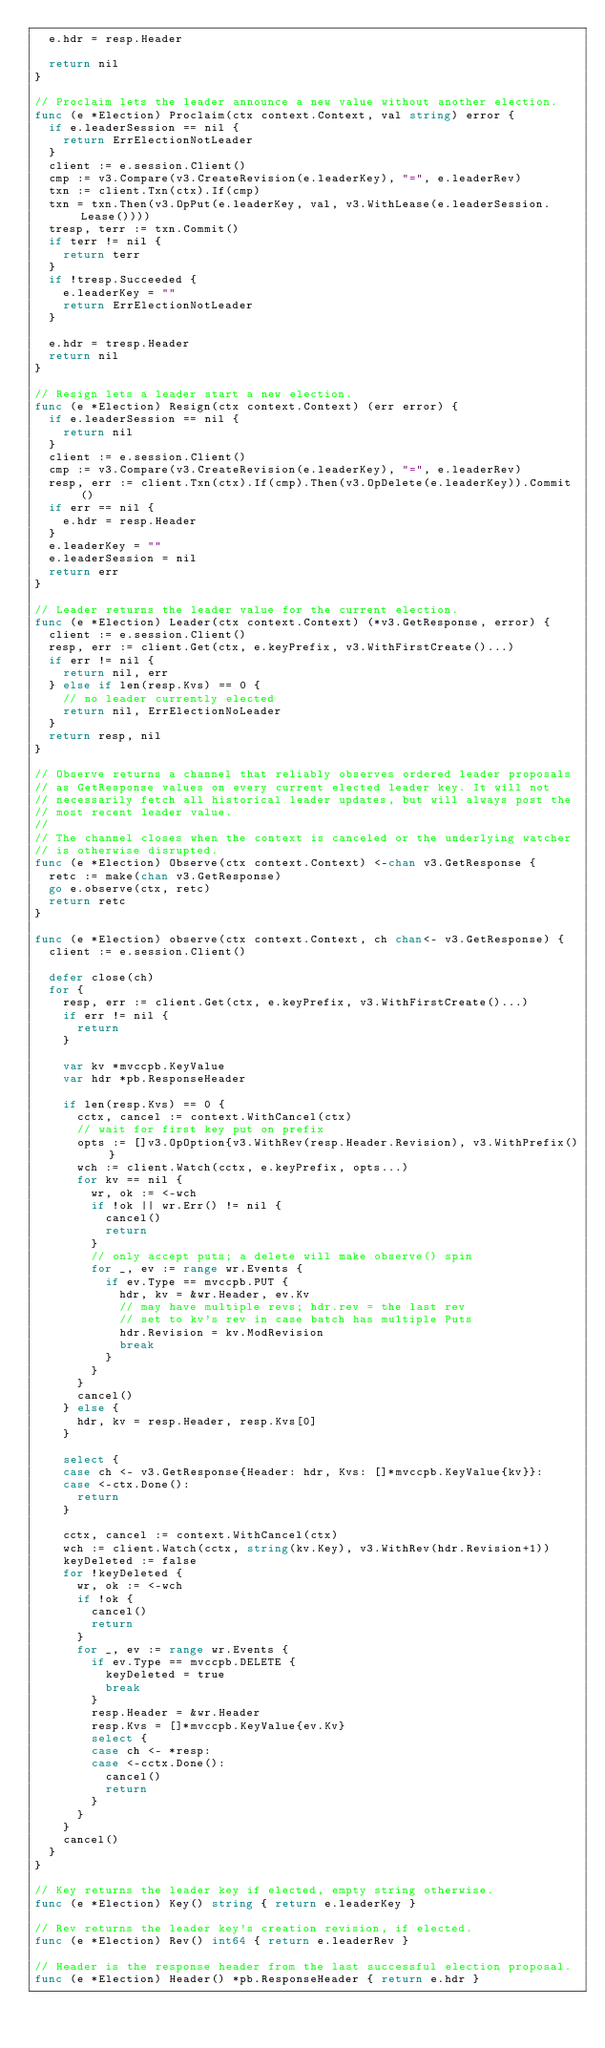<code> <loc_0><loc_0><loc_500><loc_500><_Go_>	e.hdr = resp.Header

	return nil
}

// Proclaim lets the leader announce a new value without another election.
func (e *Election) Proclaim(ctx context.Context, val string) error {
	if e.leaderSession == nil {
		return ErrElectionNotLeader
	}
	client := e.session.Client()
	cmp := v3.Compare(v3.CreateRevision(e.leaderKey), "=", e.leaderRev)
	txn := client.Txn(ctx).If(cmp)
	txn = txn.Then(v3.OpPut(e.leaderKey, val, v3.WithLease(e.leaderSession.Lease())))
	tresp, terr := txn.Commit()
	if terr != nil {
		return terr
	}
	if !tresp.Succeeded {
		e.leaderKey = ""
		return ErrElectionNotLeader
	}

	e.hdr = tresp.Header
	return nil
}

// Resign lets a leader start a new election.
func (e *Election) Resign(ctx context.Context) (err error) {
	if e.leaderSession == nil {
		return nil
	}
	client := e.session.Client()
	cmp := v3.Compare(v3.CreateRevision(e.leaderKey), "=", e.leaderRev)
	resp, err := client.Txn(ctx).If(cmp).Then(v3.OpDelete(e.leaderKey)).Commit()
	if err == nil {
		e.hdr = resp.Header
	}
	e.leaderKey = ""
	e.leaderSession = nil
	return err
}

// Leader returns the leader value for the current election.
func (e *Election) Leader(ctx context.Context) (*v3.GetResponse, error) {
	client := e.session.Client()
	resp, err := client.Get(ctx, e.keyPrefix, v3.WithFirstCreate()...)
	if err != nil {
		return nil, err
	} else if len(resp.Kvs) == 0 {
		// no leader currently elected
		return nil, ErrElectionNoLeader
	}
	return resp, nil
}

// Observe returns a channel that reliably observes ordered leader proposals
// as GetResponse values on every current elected leader key. It will not
// necessarily fetch all historical leader updates, but will always post the
// most recent leader value.
//
// The channel closes when the context is canceled or the underlying watcher
// is otherwise disrupted.
func (e *Election) Observe(ctx context.Context) <-chan v3.GetResponse {
	retc := make(chan v3.GetResponse)
	go e.observe(ctx, retc)
	return retc
}

func (e *Election) observe(ctx context.Context, ch chan<- v3.GetResponse) {
	client := e.session.Client()

	defer close(ch)
	for {
		resp, err := client.Get(ctx, e.keyPrefix, v3.WithFirstCreate()...)
		if err != nil {
			return
		}

		var kv *mvccpb.KeyValue
		var hdr *pb.ResponseHeader

		if len(resp.Kvs) == 0 {
			cctx, cancel := context.WithCancel(ctx)
			// wait for first key put on prefix
			opts := []v3.OpOption{v3.WithRev(resp.Header.Revision), v3.WithPrefix()}
			wch := client.Watch(cctx, e.keyPrefix, opts...)
			for kv == nil {
				wr, ok := <-wch
				if !ok || wr.Err() != nil {
					cancel()
					return
				}
				// only accept puts; a delete will make observe() spin
				for _, ev := range wr.Events {
					if ev.Type == mvccpb.PUT {
						hdr, kv = &wr.Header, ev.Kv
						// may have multiple revs; hdr.rev = the last rev
						// set to kv's rev in case batch has multiple Puts
						hdr.Revision = kv.ModRevision
						break
					}
				}
			}
			cancel()
		} else {
			hdr, kv = resp.Header, resp.Kvs[0]
		}

		select {
		case ch <- v3.GetResponse{Header: hdr, Kvs: []*mvccpb.KeyValue{kv}}:
		case <-ctx.Done():
			return
		}

		cctx, cancel := context.WithCancel(ctx)
		wch := client.Watch(cctx, string(kv.Key), v3.WithRev(hdr.Revision+1))
		keyDeleted := false
		for !keyDeleted {
			wr, ok := <-wch
			if !ok {
				cancel()
				return
			}
			for _, ev := range wr.Events {
				if ev.Type == mvccpb.DELETE {
					keyDeleted = true
					break
				}
				resp.Header = &wr.Header
				resp.Kvs = []*mvccpb.KeyValue{ev.Kv}
				select {
				case ch <- *resp:
				case <-cctx.Done():
					cancel()
					return
				}
			}
		}
		cancel()
	}
}

// Key returns the leader key if elected, empty string otherwise.
func (e *Election) Key() string { return e.leaderKey }

// Rev returns the leader key's creation revision, if elected.
func (e *Election) Rev() int64 { return e.leaderRev }

// Header is the response header from the last successful election proposal.
func (e *Election) Header() *pb.ResponseHeader { return e.hdr }
</code> 